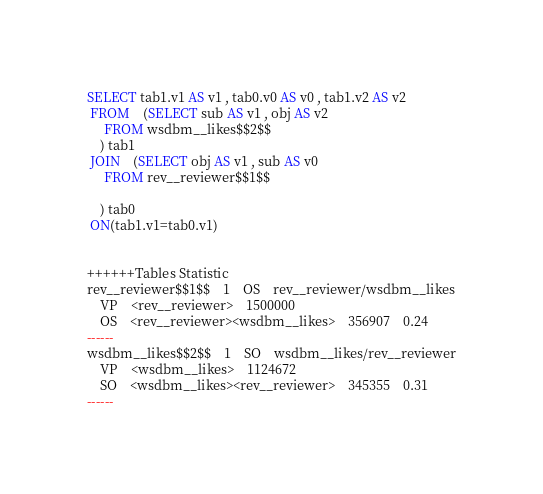Convert code to text. <code><loc_0><loc_0><loc_500><loc_500><_SQL_>SELECT tab1.v1 AS v1 , tab0.v0 AS v0 , tab1.v2 AS v2 
 FROM    (SELECT sub AS v1 , obj AS v2 
	 FROM wsdbm__likes$$2$$
	) tab1
 JOIN    (SELECT obj AS v1 , sub AS v0 
	 FROM rev__reviewer$$1$$
	
	) tab0
 ON(tab1.v1=tab0.v1)


++++++Tables Statistic
rev__reviewer$$1$$	1	OS	rev__reviewer/wsdbm__likes
	VP	<rev__reviewer>	1500000
	OS	<rev__reviewer><wsdbm__likes>	356907	0.24
------
wsdbm__likes$$2$$	1	SO	wsdbm__likes/rev__reviewer
	VP	<wsdbm__likes>	1124672
	SO	<wsdbm__likes><rev__reviewer>	345355	0.31
------
</code> 